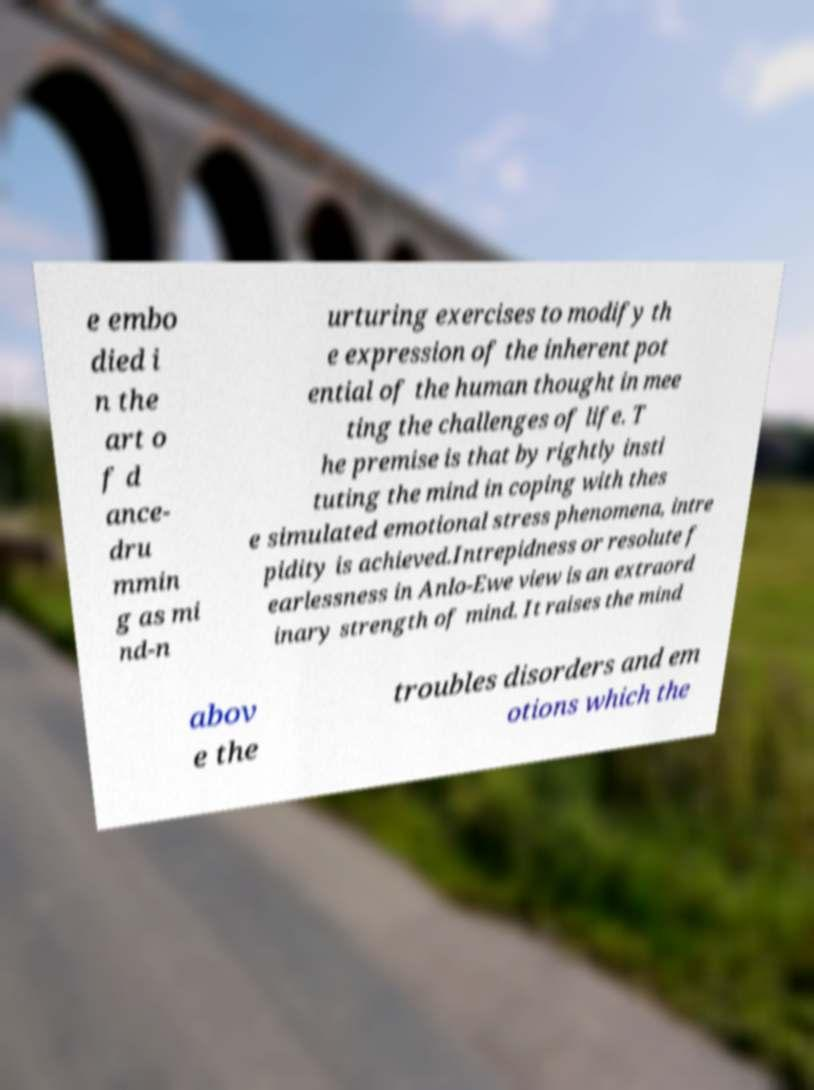I need the written content from this picture converted into text. Can you do that? e embo died i n the art o f d ance- dru mmin g as mi nd-n urturing exercises to modify th e expression of the inherent pot ential of the human thought in mee ting the challenges of life. T he premise is that by rightly insti tuting the mind in coping with thes e simulated emotional stress phenomena, intre pidity is achieved.Intrepidness or resolute f earlessness in Anlo-Ewe view is an extraord inary strength of mind. It raises the mind abov e the troubles disorders and em otions which the 